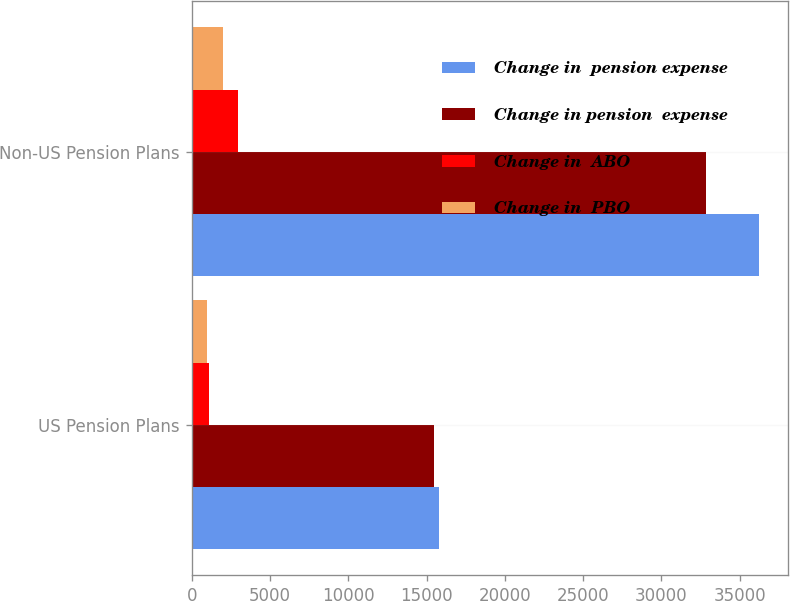Convert chart. <chart><loc_0><loc_0><loc_500><loc_500><stacked_bar_chart><ecel><fcel>US Pension Plans<fcel>Non-US Pension Plans<nl><fcel>Change in  pension expense<fcel>15781<fcel>36246<nl><fcel>Change in pension  expense<fcel>15460<fcel>32866<nl><fcel>Change in  ABO<fcel>1085<fcel>2932<nl><fcel>Change in  PBO<fcel>947<fcel>1989<nl></chart> 